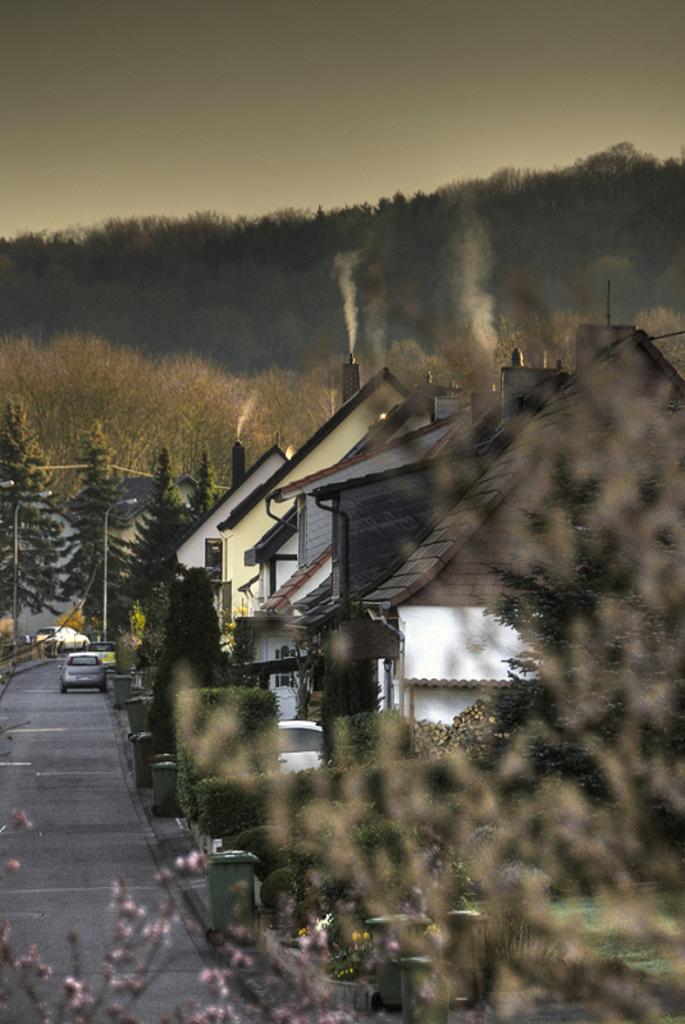Describe this image in one or two sentences. In this picture there are houses and trees in the center of the image and there are cars on the left side of the image and there are trees in the background area of the image. 